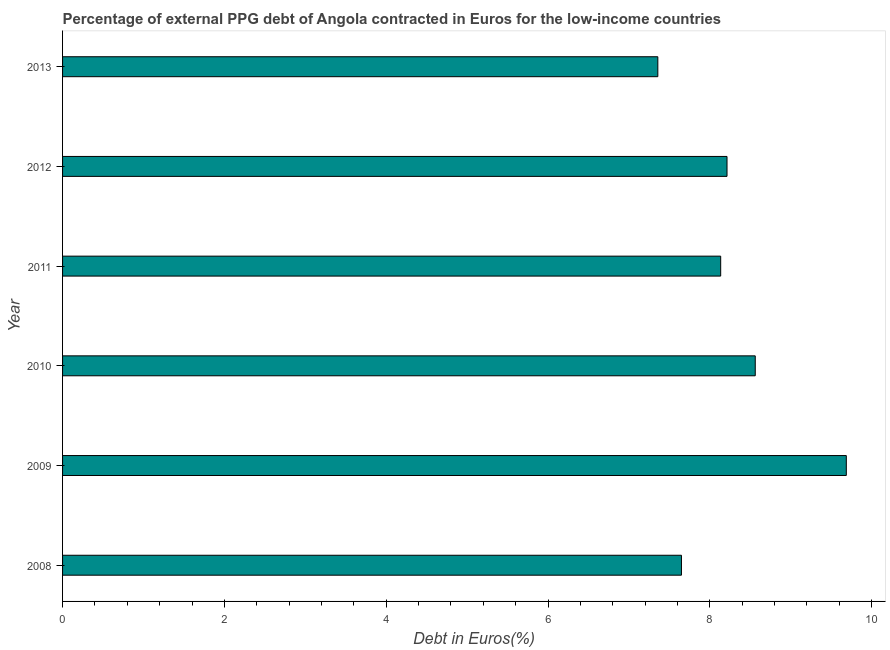Does the graph contain any zero values?
Provide a short and direct response. No. Does the graph contain grids?
Provide a succinct answer. No. What is the title of the graph?
Your response must be concise. Percentage of external PPG debt of Angola contracted in Euros for the low-income countries. What is the label or title of the X-axis?
Your response must be concise. Debt in Euros(%). What is the currency composition of ppg debt in 2013?
Make the answer very short. 7.36. Across all years, what is the maximum currency composition of ppg debt?
Give a very brief answer. 9.69. Across all years, what is the minimum currency composition of ppg debt?
Offer a terse response. 7.36. What is the sum of the currency composition of ppg debt?
Your answer should be very brief. 49.6. What is the difference between the currency composition of ppg debt in 2010 and 2012?
Your answer should be compact. 0.35. What is the average currency composition of ppg debt per year?
Offer a terse response. 8.27. What is the median currency composition of ppg debt?
Provide a short and direct response. 8.17. In how many years, is the currency composition of ppg debt greater than 6.4 %?
Keep it short and to the point. 6. What is the ratio of the currency composition of ppg debt in 2011 to that in 2013?
Make the answer very short. 1.11. Is the difference between the currency composition of ppg debt in 2010 and 2011 greater than the difference between any two years?
Ensure brevity in your answer.  No. Is the sum of the currency composition of ppg debt in 2010 and 2011 greater than the maximum currency composition of ppg debt across all years?
Your response must be concise. Yes. What is the difference between the highest and the lowest currency composition of ppg debt?
Offer a very short reply. 2.33. In how many years, is the currency composition of ppg debt greater than the average currency composition of ppg debt taken over all years?
Make the answer very short. 2. How many bars are there?
Give a very brief answer. 6. Are all the bars in the graph horizontal?
Make the answer very short. Yes. What is the difference between two consecutive major ticks on the X-axis?
Your answer should be very brief. 2. What is the Debt in Euros(%) of 2008?
Offer a terse response. 7.65. What is the Debt in Euros(%) of 2009?
Offer a very short reply. 9.69. What is the Debt in Euros(%) in 2010?
Offer a very short reply. 8.56. What is the Debt in Euros(%) in 2011?
Your answer should be compact. 8.13. What is the Debt in Euros(%) of 2012?
Offer a very short reply. 8.21. What is the Debt in Euros(%) of 2013?
Give a very brief answer. 7.36. What is the difference between the Debt in Euros(%) in 2008 and 2009?
Provide a short and direct response. -2.04. What is the difference between the Debt in Euros(%) in 2008 and 2010?
Give a very brief answer. -0.91. What is the difference between the Debt in Euros(%) in 2008 and 2011?
Your answer should be compact. -0.48. What is the difference between the Debt in Euros(%) in 2008 and 2012?
Offer a very short reply. -0.56. What is the difference between the Debt in Euros(%) in 2008 and 2013?
Make the answer very short. 0.29. What is the difference between the Debt in Euros(%) in 2009 and 2010?
Give a very brief answer. 1.13. What is the difference between the Debt in Euros(%) in 2009 and 2011?
Offer a very short reply. 1.55. What is the difference between the Debt in Euros(%) in 2009 and 2012?
Provide a short and direct response. 1.47. What is the difference between the Debt in Euros(%) in 2009 and 2013?
Your response must be concise. 2.33. What is the difference between the Debt in Euros(%) in 2010 and 2011?
Give a very brief answer. 0.43. What is the difference between the Debt in Euros(%) in 2010 and 2012?
Your response must be concise. 0.35. What is the difference between the Debt in Euros(%) in 2010 and 2013?
Keep it short and to the point. 1.2. What is the difference between the Debt in Euros(%) in 2011 and 2012?
Make the answer very short. -0.08. What is the difference between the Debt in Euros(%) in 2011 and 2013?
Your response must be concise. 0.78. What is the difference between the Debt in Euros(%) in 2012 and 2013?
Make the answer very short. 0.86. What is the ratio of the Debt in Euros(%) in 2008 to that in 2009?
Give a very brief answer. 0.79. What is the ratio of the Debt in Euros(%) in 2008 to that in 2010?
Keep it short and to the point. 0.89. What is the ratio of the Debt in Euros(%) in 2008 to that in 2013?
Your answer should be compact. 1.04. What is the ratio of the Debt in Euros(%) in 2009 to that in 2010?
Offer a terse response. 1.13. What is the ratio of the Debt in Euros(%) in 2009 to that in 2011?
Your answer should be compact. 1.19. What is the ratio of the Debt in Euros(%) in 2009 to that in 2012?
Your answer should be compact. 1.18. What is the ratio of the Debt in Euros(%) in 2009 to that in 2013?
Make the answer very short. 1.32. What is the ratio of the Debt in Euros(%) in 2010 to that in 2011?
Give a very brief answer. 1.05. What is the ratio of the Debt in Euros(%) in 2010 to that in 2012?
Offer a terse response. 1.04. What is the ratio of the Debt in Euros(%) in 2010 to that in 2013?
Ensure brevity in your answer.  1.16. What is the ratio of the Debt in Euros(%) in 2011 to that in 2012?
Offer a terse response. 0.99. What is the ratio of the Debt in Euros(%) in 2011 to that in 2013?
Your answer should be very brief. 1.11. What is the ratio of the Debt in Euros(%) in 2012 to that in 2013?
Ensure brevity in your answer.  1.12. 